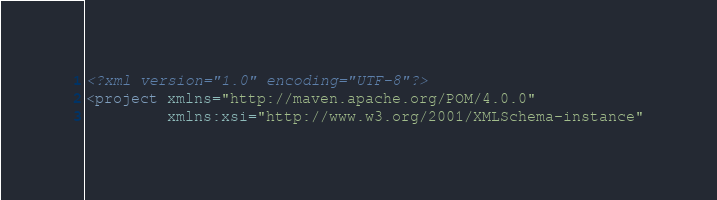Convert code to text. <code><loc_0><loc_0><loc_500><loc_500><_XML_><?xml version="1.0" encoding="UTF-8"?>
<project xmlns="http://maven.apache.org/POM/4.0.0"
         xmlns:xsi="http://www.w3.org/2001/XMLSchema-instance"</code> 